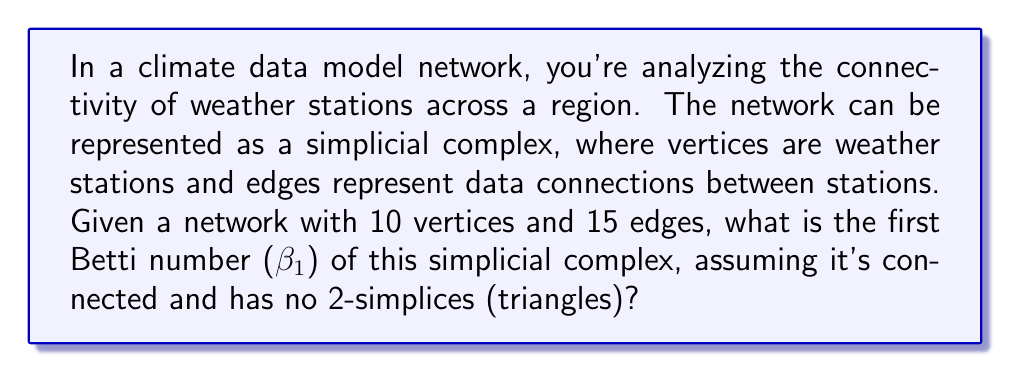Could you help me with this problem? To solve this problem, we need to understand the concept of Betti numbers in algebraic topology and how they relate to the given network structure. Let's break it down step-by-step:

1) The first Betti number (β₁) represents the number of 1-dimensional holes in the simplicial complex. In network terms, it's the number of independent cycles or loops.

2) For a connected simplicial complex with only 0-simplices (vertices) and 1-simplices (edges), we can use the Euler characteristic formula:

   $$\chi = V - E + F$$

   Where:
   $\chi$ is the Euler characteristic
   $V$ is the number of vertices
   $E$ is the number of edges
   $F$ is the number of faces (2-simplices)

3) In this case, we're given that there are no 2-simplices, so $F = 0$.

4) We're also given that $V = 10$ and $E = 15$.

5) Substituting these values into the Euler characteristic formula:

   $$\chi = 10 - 15 + 0 = -5$$

6) For a connected simplicial complex, the Euler characteristic is related to the Betti numbers by:

   $$\chi = \beta_0 - \beta_1 + \beta_2$$

   Where $\beta_0$ is the 0th Betti number (number of connected components), $\beta_1$ is the 1st Betti number (number of 1-dimensional holes), and $\beta_2$ is the 2nd Betti number (number of 2-dimensional voids).

7) We know the complex is connected, so $\beta_0 = 1$. There are no 2-simplices, so $\beta_2 = 0$.

8) Substituting into the Betti number formula:

   $$-5 = 1 - \beta_1 + 0$$

9) Solving for $\beta_1$:

   $$\beta_1 = 1 - (-5) = 6$$

Therefore, the first Betti number of this simplicial complex is 6, indicating 6 independent cycles in the network.
Answer: $\beta_1 = 6$ 